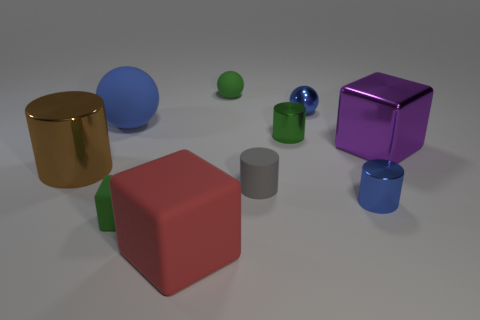There is a rubber thing that is the same color as the small matte block; what is its shape?
Provide a short and direct response. Sphere. There is a green object that is left of the red matte block in front of the purple thing; is there a small gray thing that is to the left of it?
Provide a short and direct response. No. Do the blue shiny sphere and the gray object have the same size?
Your response must be concise. Yes. Are there the same number of things in front of the large brown metallic cylinder and purple metallic things behind the big purple thing?
Offer a very short reply. No. The small blue metallic thing that is in front of the shiny ball has what shape?
Give a very brief answer. Cylinder. The blue rubber object that is the same size as the brown shiny thing is what shape?
Offer a terse response. Sphere. The rubber sphere on the left side of the big object in front of the blue thing that is in front of the small matte cylinder is what color?
Your answer should be very brief. Blue. Do the red rubber thing and the green metal object have the same shape?
Provide a succinct answer. No. Are there an equal number of big brown metal things that are right of the green sphere and small gray rubber things?
Offer a very short reply. No. How many other things are there of the same material as the big brown cylinder?
Offer a terse response. 4. 